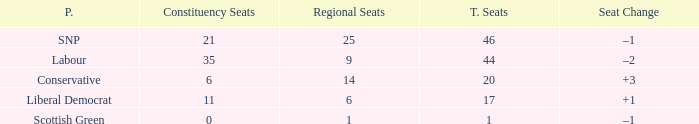What is the full number of Total Seats with a constituency seat number bigger than 0 with the Liberal Democrat party, and the Regional seat number is smaller than 6? None. 